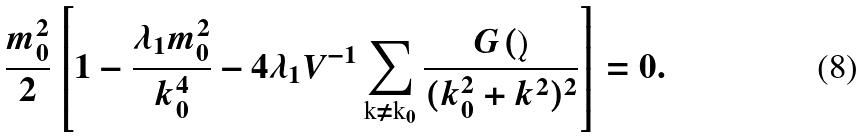Convert formula to latex. <formula><loc_0><loc_0><loc_500><loc_500>\frac { m _ { 0 } ^ { 2 } } { 2 } \left [ 1 - \frac { \lambda _ { 1 } m _ { 0 } ^ { 2 } } { k _ { 0 } ^ { 4 } } - 4 \lambda _ { 1 } V ^ { - 1 } \sum _ { { \text  k}\neq{\text  k}_{0}} \frac{G(\k)} {(k_{0}^{2}+k^{2})^{2}}\right]=0.</formula> 